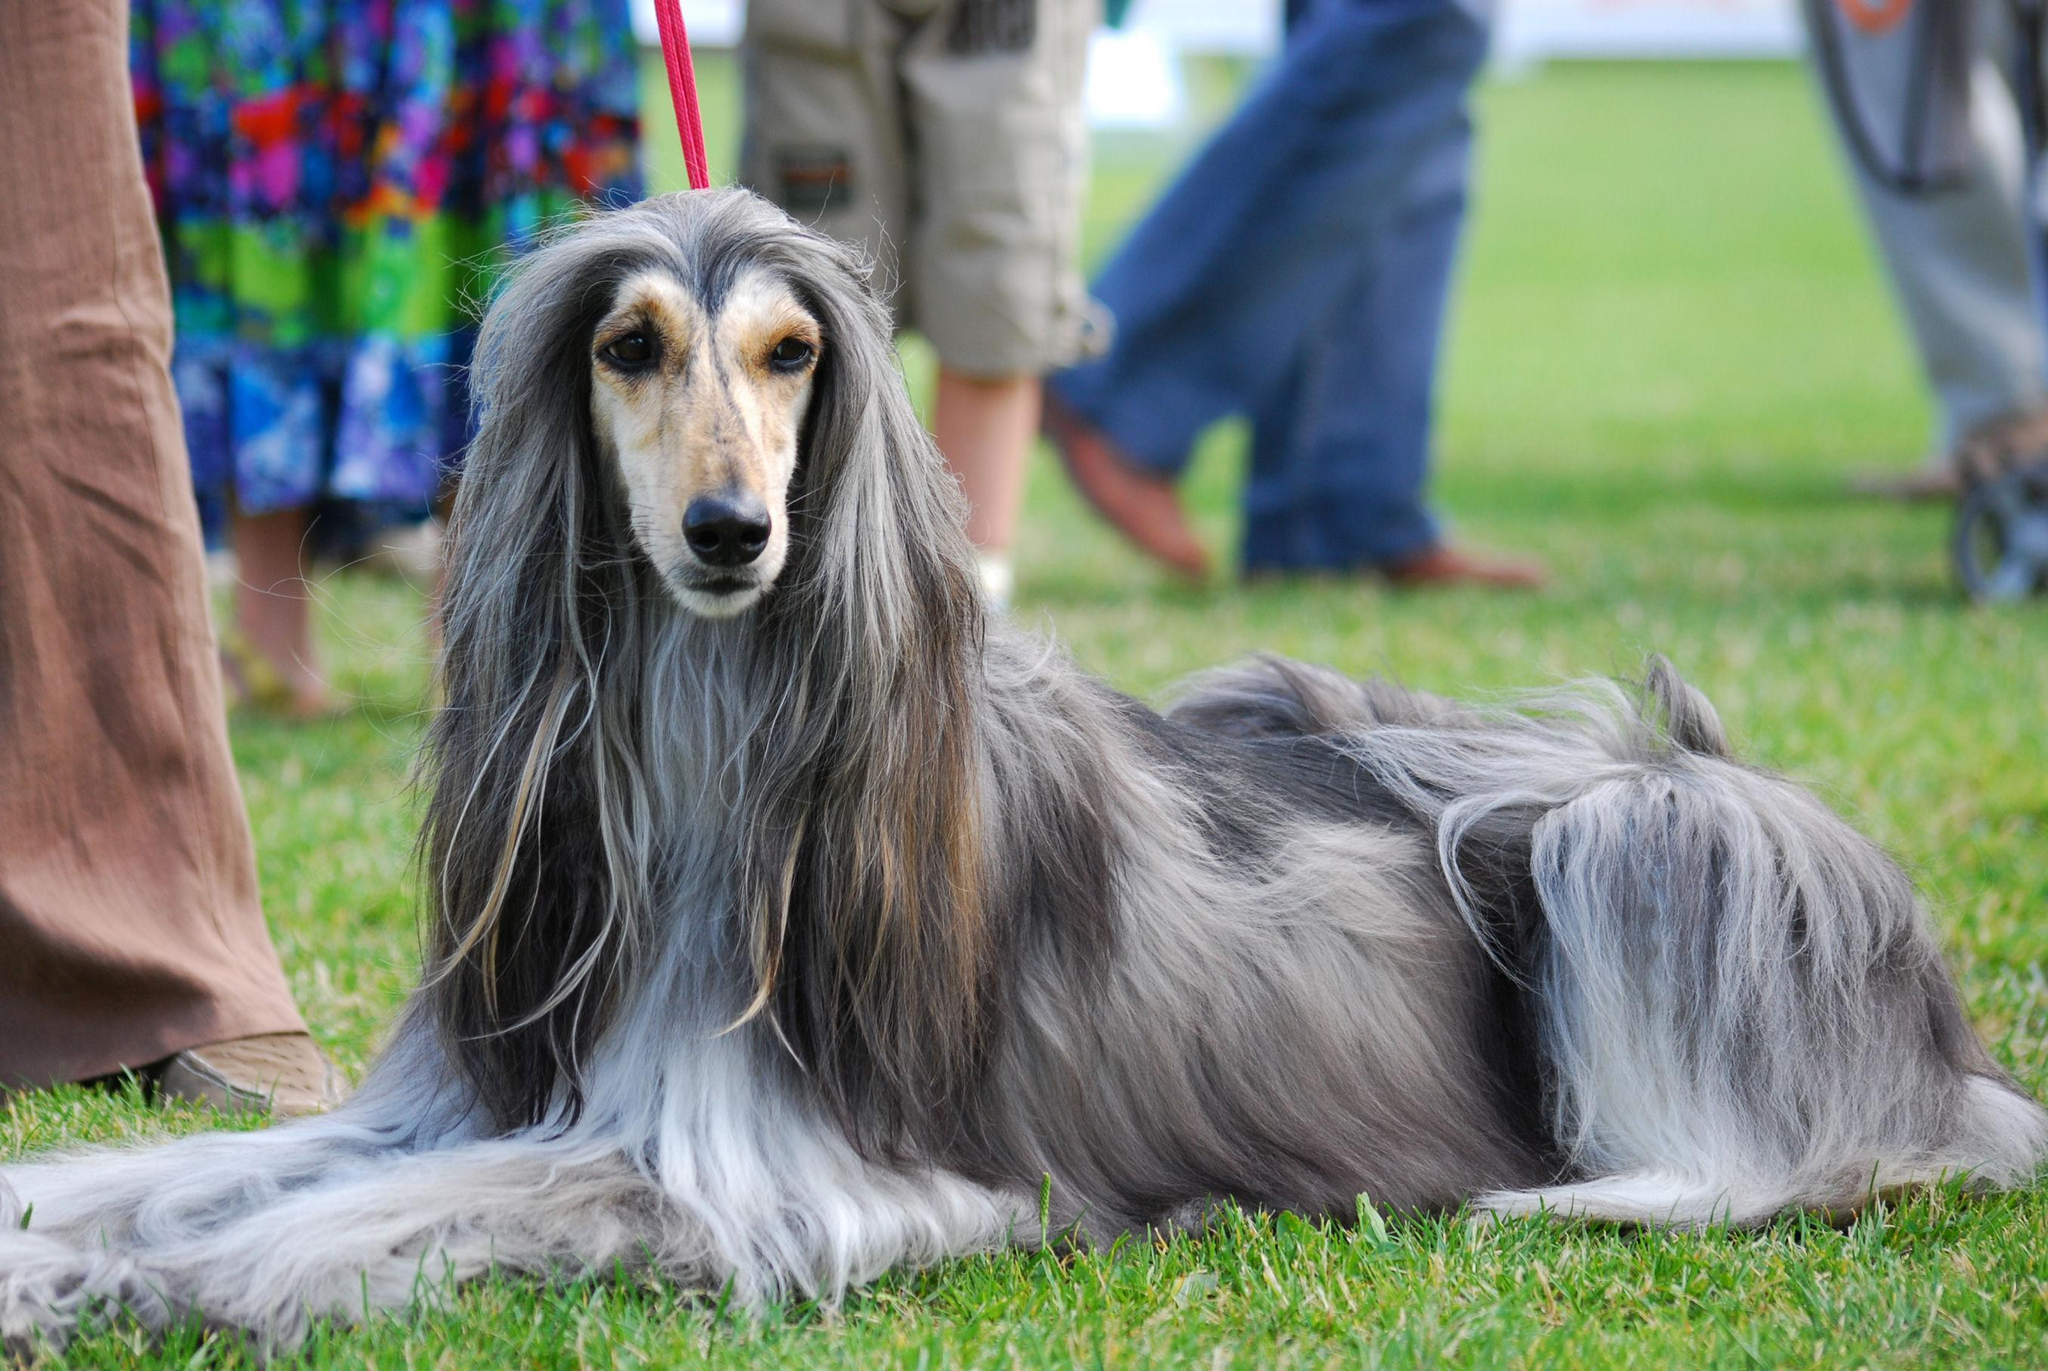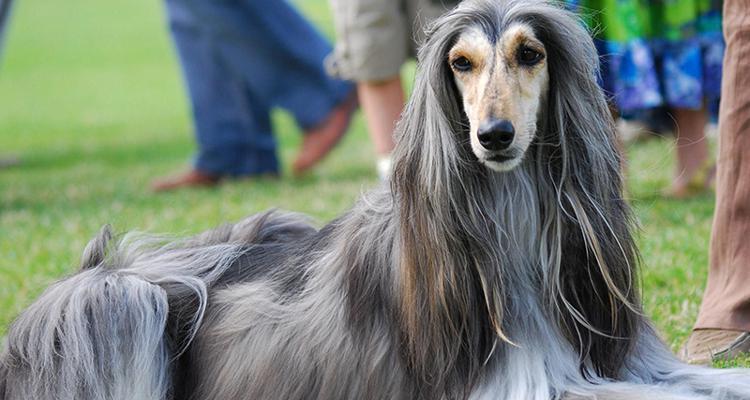The first image is the image on the left, the second image is the image on the right. Analyze the images presented: Is the assertion "All dogs shown have mostly gray fur." valid? Answer yes or no. Yes. 